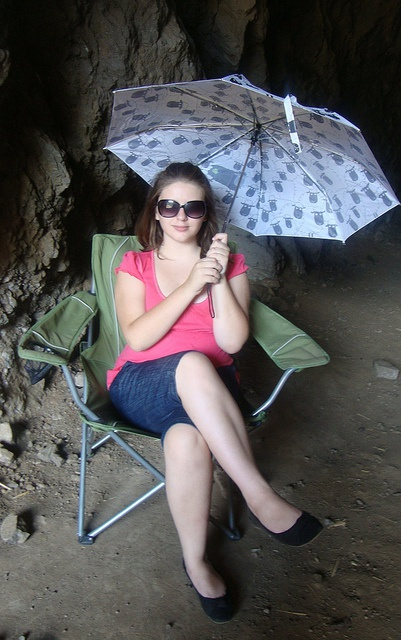Describe the objects in this image and their specific colors. I can see people in black, lightgray, darkgray, and pink tones, umbrella in black, gray, darkgray, and lightblue tones, and chair in black, gray, and darkgray tones in this image. 